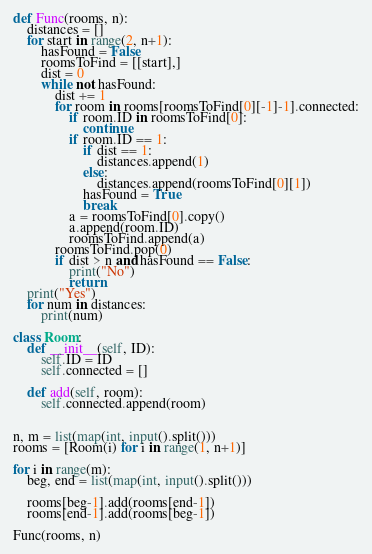<code> <loc_0><loc_0><loc_500><loc_500><_Python_>def Func(rooms, n):
	distances = []
	for start in range(2, n+1):
		hasFound = False
		roomsToFind = [[start],]
		dist = 0
		while not hasFound:
			dist += 1
			for room in rooms[roomsToFind[0][-1]-1].connected:
				if room.ID in roomsToFind[0]:
					continue
				if room.ID == 1:
					if dist == 1:
						distances.append(1)
					else:
						distances.append(roomsToFind[0][1])
					hasFound = True
					break
				a = roomsToFind[0].copy()
				a.append(room.ID)
				roomsToFind.append(a)
			roomsToFind.pop(0)
			if dist > n and hasFound == False:
				print("No")
				return
	print("Yes")
	for num in distances:
		print(num)

class Room:
	def __init__(self, ID):
		self.ID = ID
		self.connected = []

	def add(self, room):
		self.connected.append(room)


n, m = list(map(int, input().split()))
rooms = [Room(i) for i in range(1, n+1)]

for i in range(m):
	beg, end = list(map(int, input().split()))

	rooms[beg-1].add(rooms[end-1])
	rooms[end-1].add(rooms[beg-1])

Func(rooms, n)</code> 